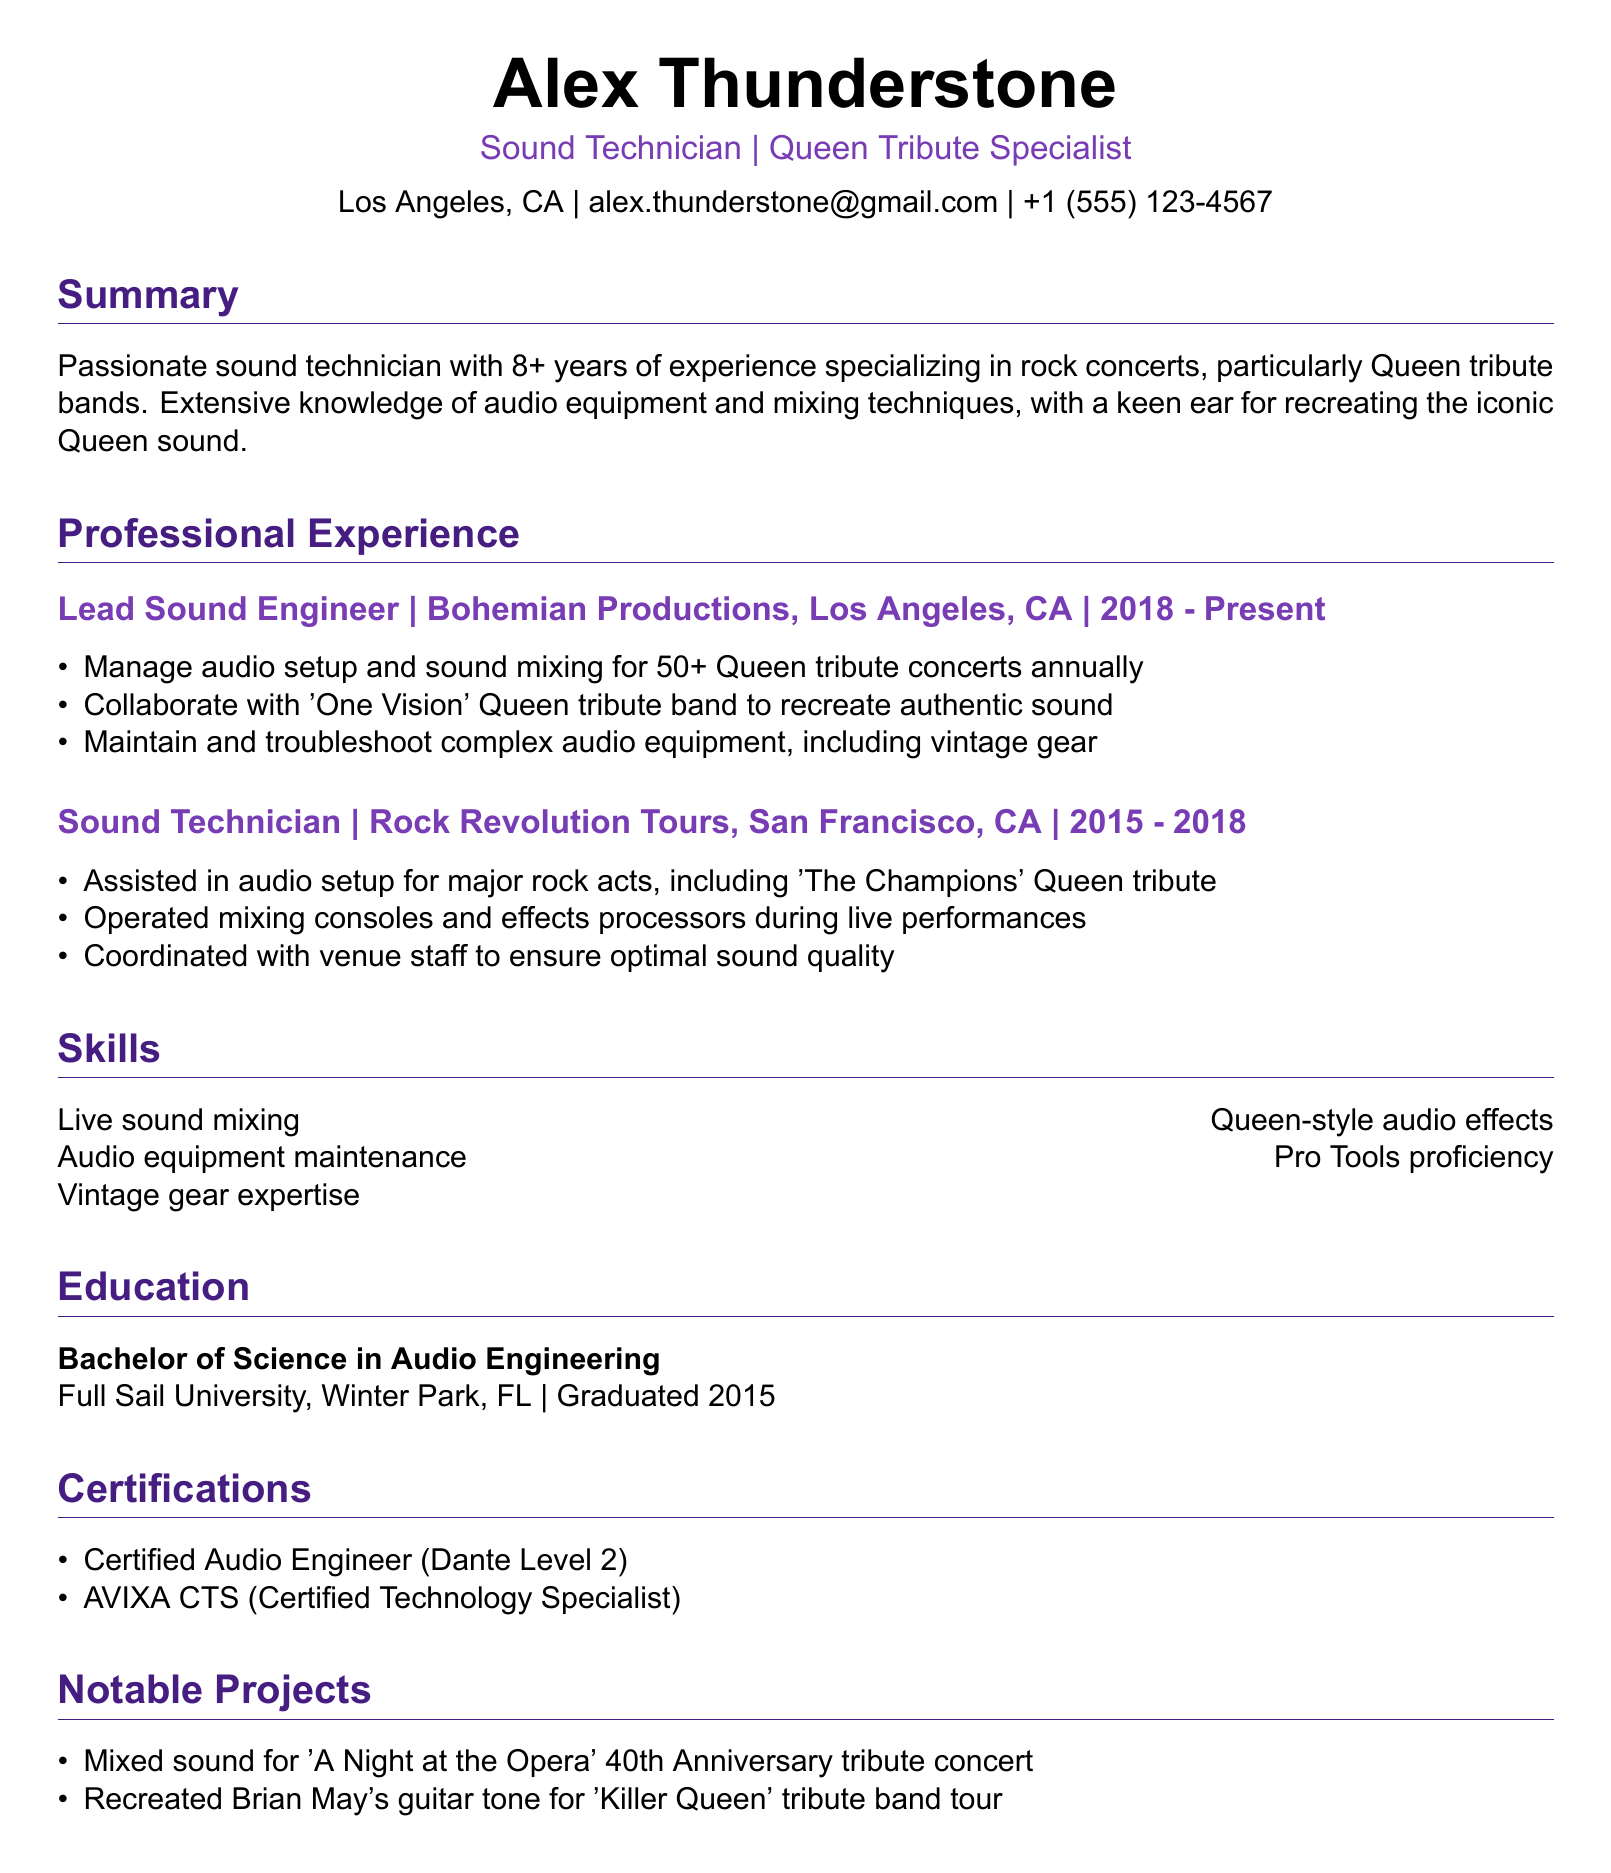what is the name of the individual? The name of the individual is listed at the top of the document.
Answer: Alex Thunderstone how many years of experience does the individual have? The summary mentions the individual's experience in years.
Answer: 8+ what is the role of the individual at Bohemian Productions? The document specifies the title of the individual's position in their current job.
Answer: Lead Sound Engineer in which city is Bohemian Productions located? The work experience section states the location of the company.
Answer: Los Angeles, CA what certification does the individual have that relates to audio engineering? The certifications section lists the qualifications the individual has achieved.
Answer: Certified Audio Engineer (Dante Level 2) which Queen tribute band did the individual collaborate with? The responsibilities of the individual's current job mention a specific band they worked with.
Answer: One Vision what notable project involved the 40th Anniversary tribute concert? The notable projects section references a specific event tied to Queen's music.
Answer: A Night at the Opera during which years did the individual work at Rock Revolution Tours? The work experience provides the timeline for the individual's previous employment.
Answer: 2015 - 2018 what degree did the individual obtain? The education section describes the individual's academic qualification.
Answer: Bachelor of Science in Audio Engineering 